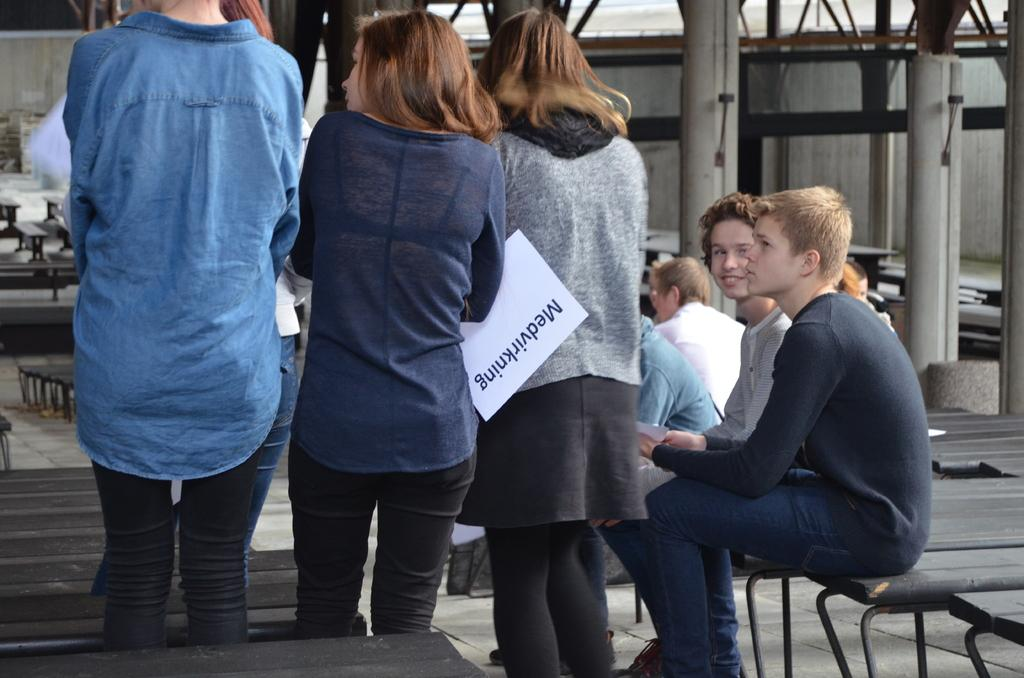How many people are in the image? There are people in the image, but the exact number is not specified. What are some of the people doing in the image? Some of the people are sitting, and some are standing. What type of furniture is present in the image? There are wooden benches in the image. What architectural features can be seen in the background of the image? There are pillars and a wall in the background of the image. What type of zinc is being used to construct the pillars in the image? There is no mention of zinc being used in the construction of the pillars in the image. Can you describe the curve of the beef in the image? There is no beef present in the image. 